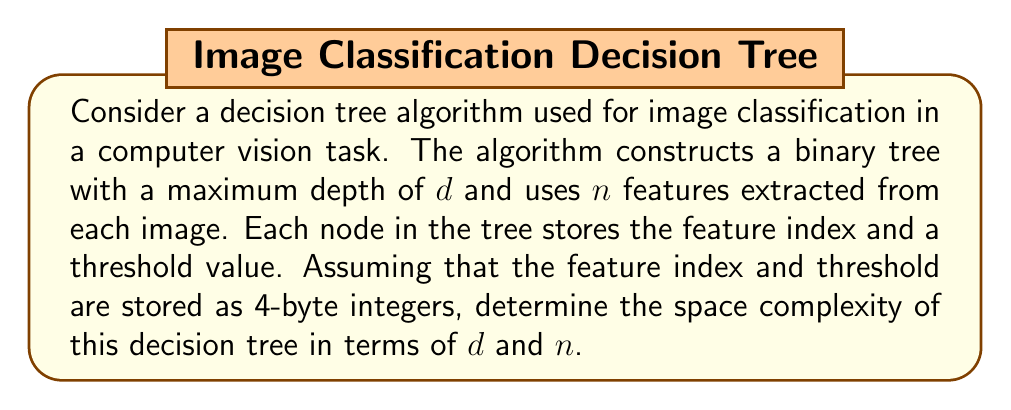Give your solution to this math problem. To determine the space complexity of the decision tree algorithm, we need to consider the following steps:

1) In a binary tree with maximum depth $d$, the maximum number of nodes is:

   $$2^{d+1} - 1$$

2) Each node stores two pieces of information:
   - Feature index (4 bytes)
   - Threshold value (4 bytes)

   So, each node requires 8 bytes of storage.

3) The total space required for the tree structure is:

   $$8 * (2^{d+1} - 1)$$ bytes

4) Additionally, we need to consider the space required to store the feature vector for each image. This is $4n$ bytes (assuming each feature is a 4-byte float).

5) The total space complexity is the sum of the tree structure and the feature vector:

   $$8 * (2^{d+1} - 1) + 4n$$ bytes

6) In Big O notation, we express this as $O(2^d + n)$.

7) However, in practice, $d$ is often limited to $\log_2(n)$ to prevent overfitting. In this case, the space complexity would simplify to $O(n)$.

For the computer vision specialist, it's important to note that this space complexity analysis helps in understanding the memory requirements of the decision tree model, which is crucial when deploying models on devices with limited memory or when working with large datasets.
Answer: The space complexity of the decision tree algorithm is $O(2^d + n)$, where $d$ is the maximum depth of the tree and $n$ is the number of features. If $d$ is limited to $\log_2(n)$, the space complexity simplifies to $O(n)$. 